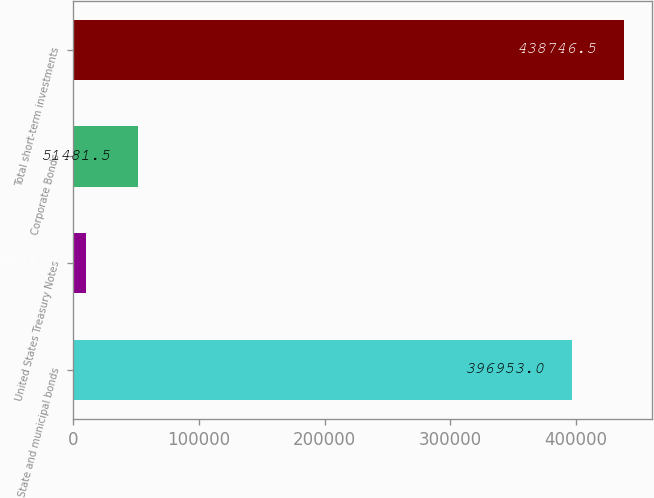Convert chart. <chart><loc_0><loc_0><loc_500><loc_500><bar_chart><fcel>State and municipal bonds<fcel>United States Treasury Notes<fcel>Corporate Bonds<fcel>Total short-term investments<nl><fcel>396953<fcel>9688<fcel>51481.5<fcel>438746<nl></chart> 